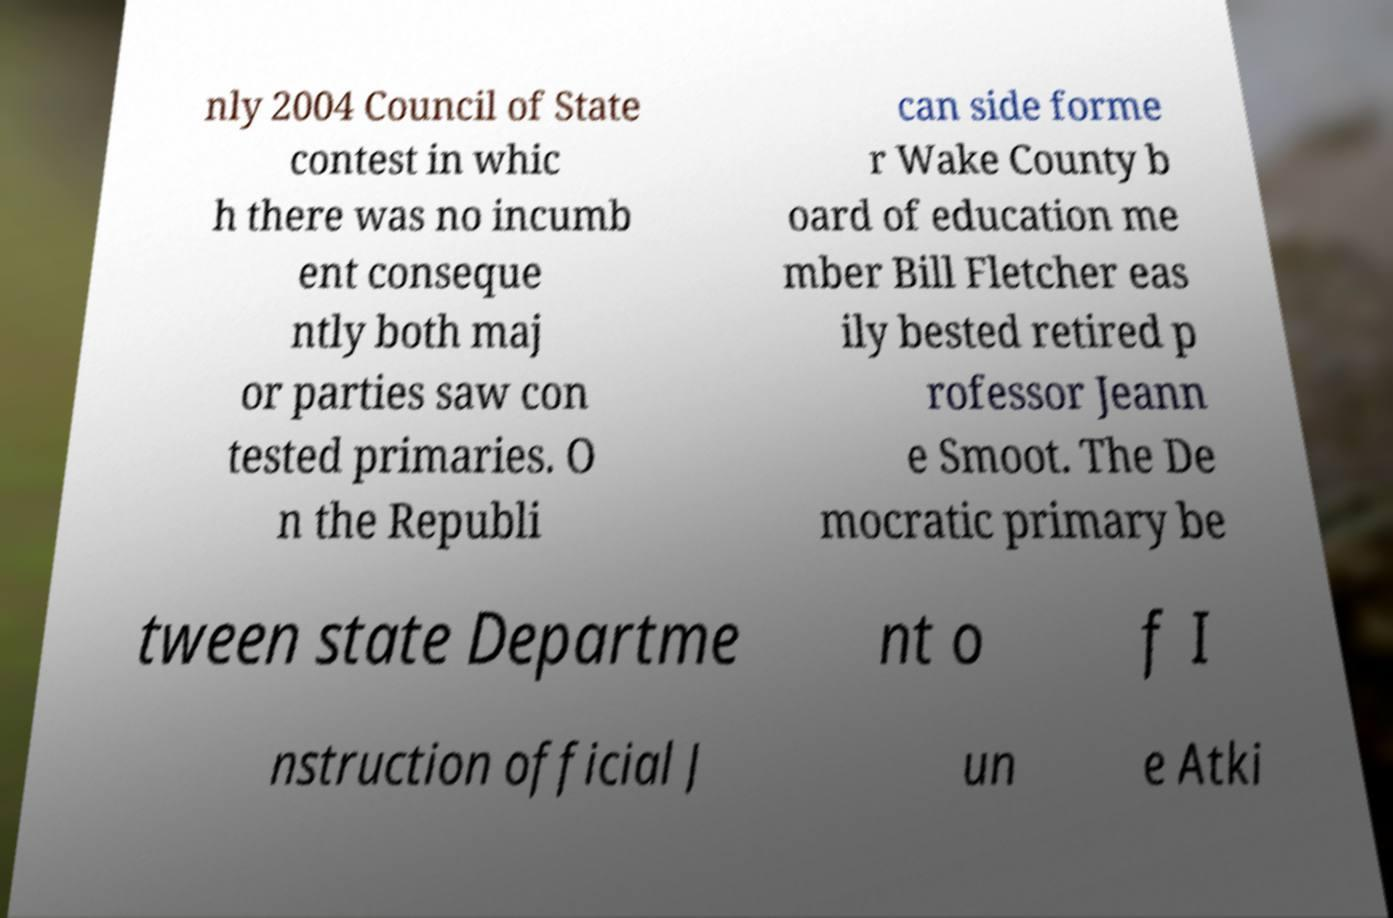Could you assist in decoding the text presented in this image and type it out clearly? nly 2004 Council of State contest in whic h there was no incumb ent conseque ntly both maj or parties saw con tested primaries. O n the Republi can side forme r Wake County b oard of education me mber Bill Fletcher eas ily bested retired p rofessor Jeann e Smoot. The De mocratic primary be tween state Departme nt o f I nstruction official J un e Atki 